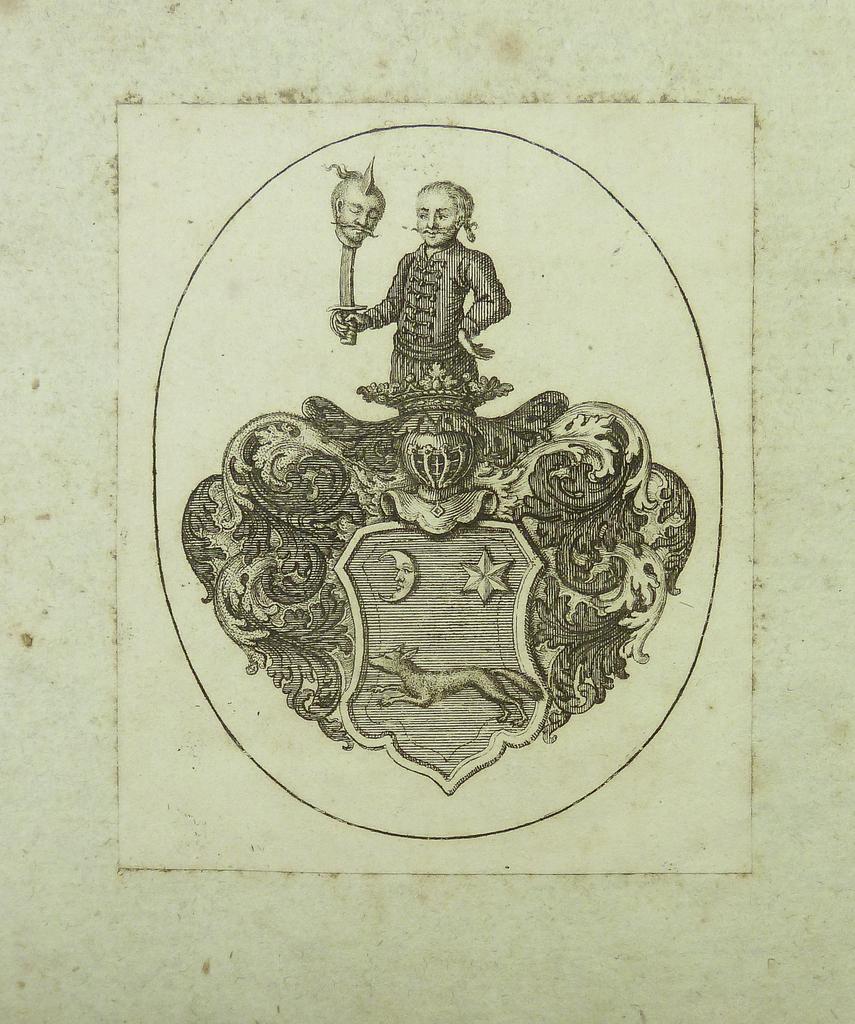Please provide a concise description of this image. In this image we can see a depiction of a person holding a sword on the paper. 